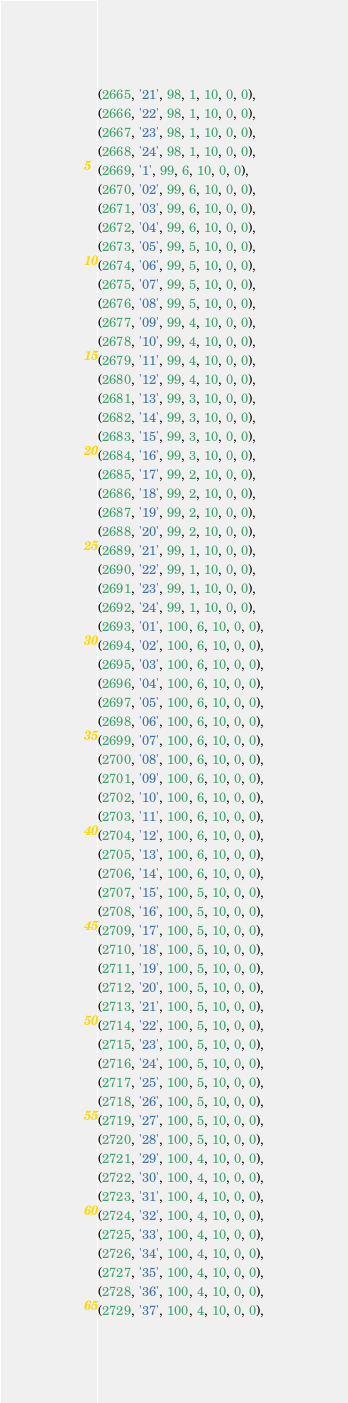<code> <loc_0><loc_0><loc_500><loc_500><_SQL_>(2665, '21', 98, 1, 10, 0, 0),
(2666, '22', 98, 1, 10, 0, 0),
(2667, '23', 98, 1, 10, 0, 0),
(2668, '24', 98, 1, 10, 0, 0),
(2669, '1', 99, 6, 10, 0, 0),
(2670, '02', 99, 6, 10, 0, 0),
(2671, '03', 99, 6, 10, 0, 0),
(2672, '04', 99, 6, 10, 0, 0),
(2673, '05', 99, 5, 10, 0, 0),
(2674, '06', 99, 5, 10, 0, 0),
(2675, '07', 99, 5, 10, 0, 0),
(2676, '08', 99, 5, 10, 0, 0),
(2677, '09', 99, 4, 10, 0, 0),
(2678, '10', 99, 4, 10, 0, 0),
(2679, '11', 99, 4, 10, 0, 0),
(2680, '12', 99, 4, 10, 0, 0),
(2681, '13', 99, 3, 10, 0, 0),
(2682, '14', 99, 3, 10, 0, 0),
(2683, '15', 99, 3, 10, 0, 0),
(2684, '16', 99, 3, 10, 0, 0),
(2685, '17', 99, 2, 10, 0, 0),
(2686, '18', 99, 2, 10, 0, 0),
(2687, '19', 99, 2, 10, 0, 0),
(2688, '20', 99, 2, 10, 0, 0),
(2689, '21', 99, 1, 10, 0, 0),
(2690, '22', 99, 1, 10, 0, 0),
(2691, '23', 99, 1, 10, 0, 0),
(2692, '24', 99, 1, 10, 0, 0),
(2693, '01', 100, 6, 10, 0, 0),
(2694, '02', 100, 6, 10, 0, 0),
(2695, '03', 100, 6, 10, 0, 0),
(2696, '04', 100, 6, 10, 0, 0),
(2697, '05', 100, 6, 10, 0, 0),
(2698, '06', 100, 6, 10, 0, 0),
(2699, '07', 100, 6, 10, 0, 0),
(2700, '08', 100, 6, 10, 0, 0),
(2701, '09', 100, 6, 10, 0, 0),
(2702, '10', 100, 6, 10, 0, 0),
(2703, '11', 100, 6, 10, 0, 0),
(2704, '12', 100, 6, 10, 0, 0),
(2705, '13', 100, 6, 10, 0, 0),
(2706, '14', 100, 6, 10, 0, 0),
(2707, '15', 100, 5, 10, 0, 0),
(2708, '16', 100, 5, 10, 0, 0),
(2709, '17', 100, 5, 10, 0, 0),
(2710, '18', 100, 5, 10, 0, 0),
(2711, '19', 100, 5, 10, 0, 0),
(2712, '20', 100, 5, 10, 0, 0),
(2713, '21', 100, 5, 10, 0, 0),
(2714, '22', 100, 5, 10, 0, 0),
(2715, '23', 100, 5, 10, 0, 0),
(2716, '24', 100, 5, 10, 0, 0),
(2717, '25', 100, 5, 10, 0, 0),
(2718, '26', 100, 5, 10, 0, 0),
(2719, '27', 100, 5, 10, 0, 0),
(2720, '28', 100, 5, 10, 0, 0),
(2721, '29', 100, 4, 10, 0, 0),
(2722, '30', 100, 4, 10, 0, 0),
(2723, '31', 100, 4, 10, 0, 0),
(2724, '32', 100, 4, 10, 0, 0),
(2725, '33', 100, 4, 10, 0, 0),
(2726, '34', 100, 4, 10, 0, 0),
(2727, '35', 100, 4, 10, 0, 0),
(2728, '36', 100, 4, 10, 0, 0),
(2729, '37', 100, 4, 10, 0, 0),</code> 